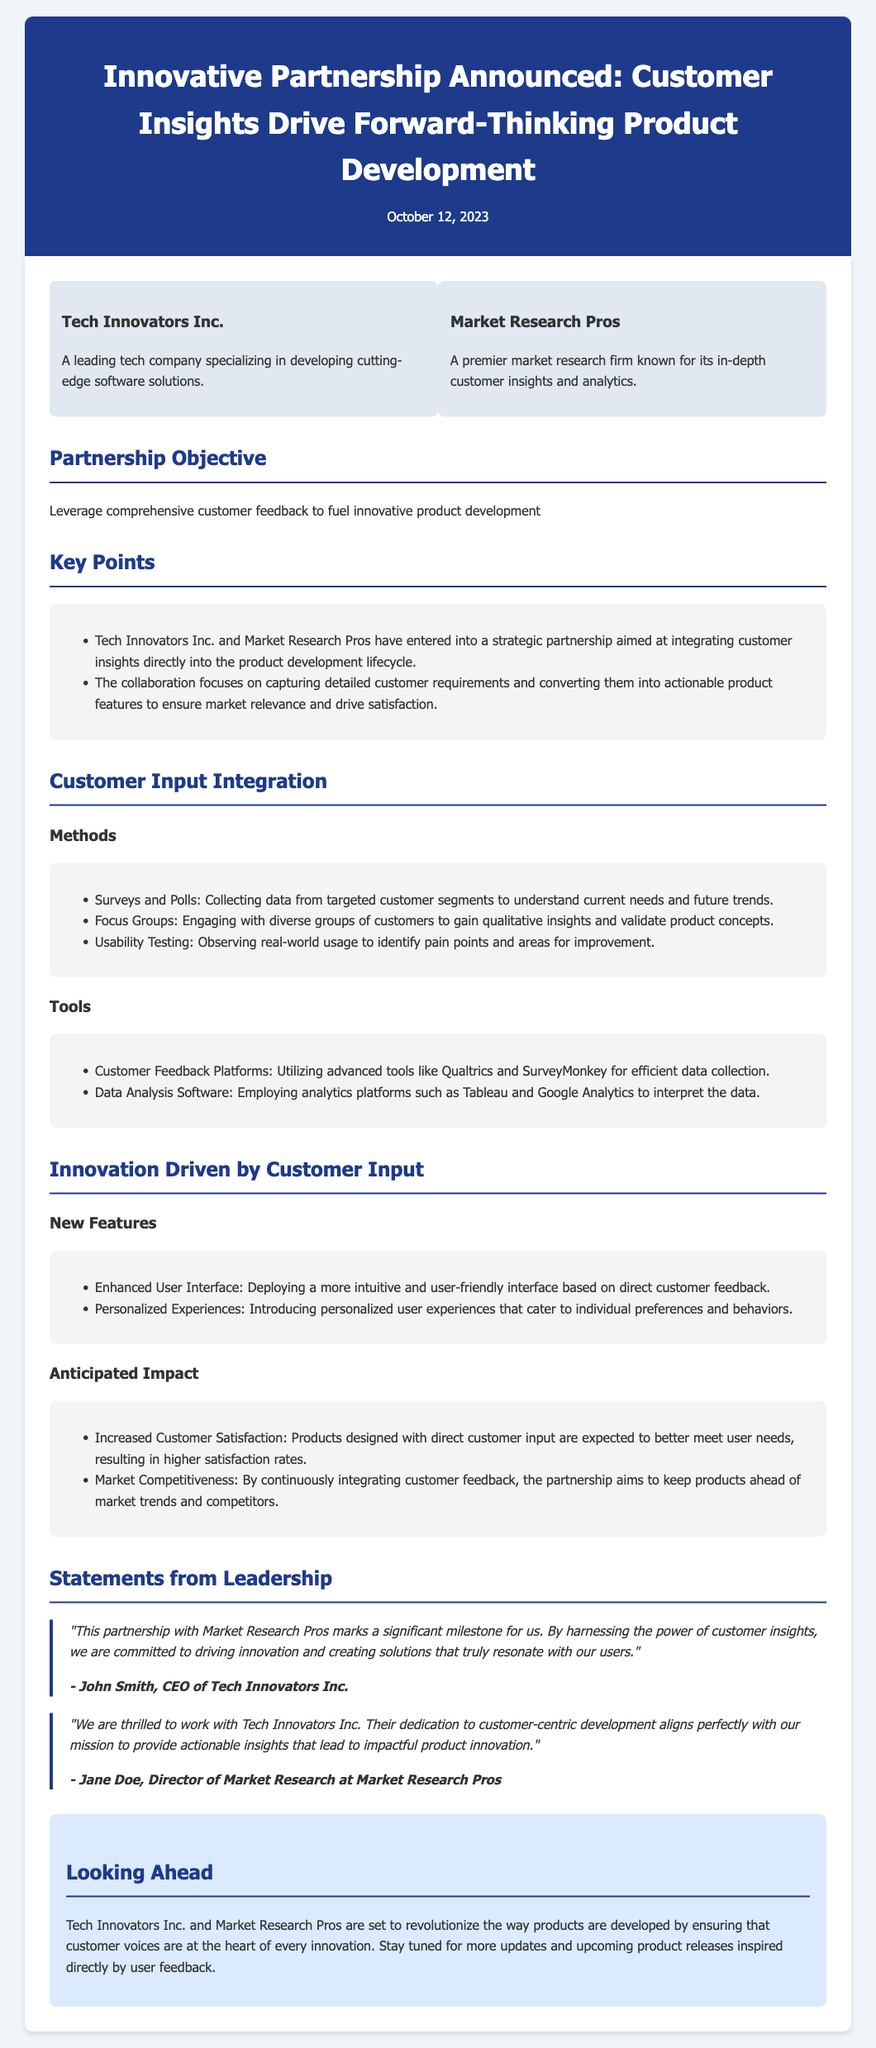What is the name of the first company involved in the partnership? The first company mentioned in the partnership is Tech Innovators Inc.
Answer: Tech Innovators Inc What date was the press release published? The press release was published on October 12, 2023.
Answer: October 12, 2023 What is the objective of the partnership? The objective of the partnership is to leverage comprehensive customer feedback to fuel innovative product development.
Answer: Leverage comprehensive customer feedback to fuel innovative product development Who is the CEO of Tech Innovators Inc.? The CEO of Tech Innovators Inc. is John Smith.
Answer: John Smith What types of methods are used to gather customer input? The methods used include Surveys and Polls, Focus Groups, and Usability Testing.
Answer: Surveys and Polls What is one expected outcome of integrating customer input? One expected outcome is Increased Customer Satisfaction.
Answer: Increased Customer Satisfaction What is a new feature introduced from customer feedback? A new feature introduced is Enhanced User Interface.
Answer: Enhanced User Interface Which two companies are mentioned in the announcement? The two companies mentioned are Tech Innovators Inc. and Market Research Pros.
Answer: Tech Innovators Inc. and Market Research Pros What is the format of the document? The document is a press release.
Answer: Press release 